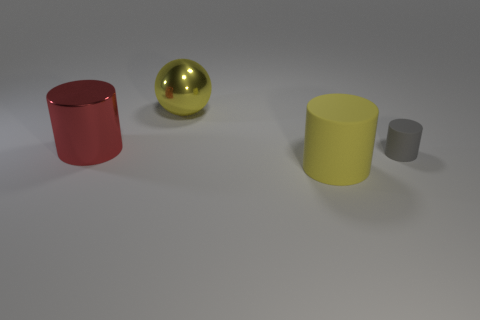Subtract all matte cylinders. How many cylinders are left? 1 Add 3 big yellow things. How many objects exist? 7 Subtract all cylinders. How many objects are left? 1 Subtract all red cylinders. How many cylinders are left? 2 Subtract all green cylinders. How many brown balls are left? 0 Subtract all yellow balls. Subtract all tiny gray cylinders. How many objects are left? 2 Add 1 metal spheres. How many metal spheres are left? 2 Add 3 large yellow spheres. How many large yellow spheres exist? 4 Subtract 0 cyan cylinders. How many objects are left? 4 Subtract all purple cylinders. Subtract all purple balls. How many cylinders are left? 3 